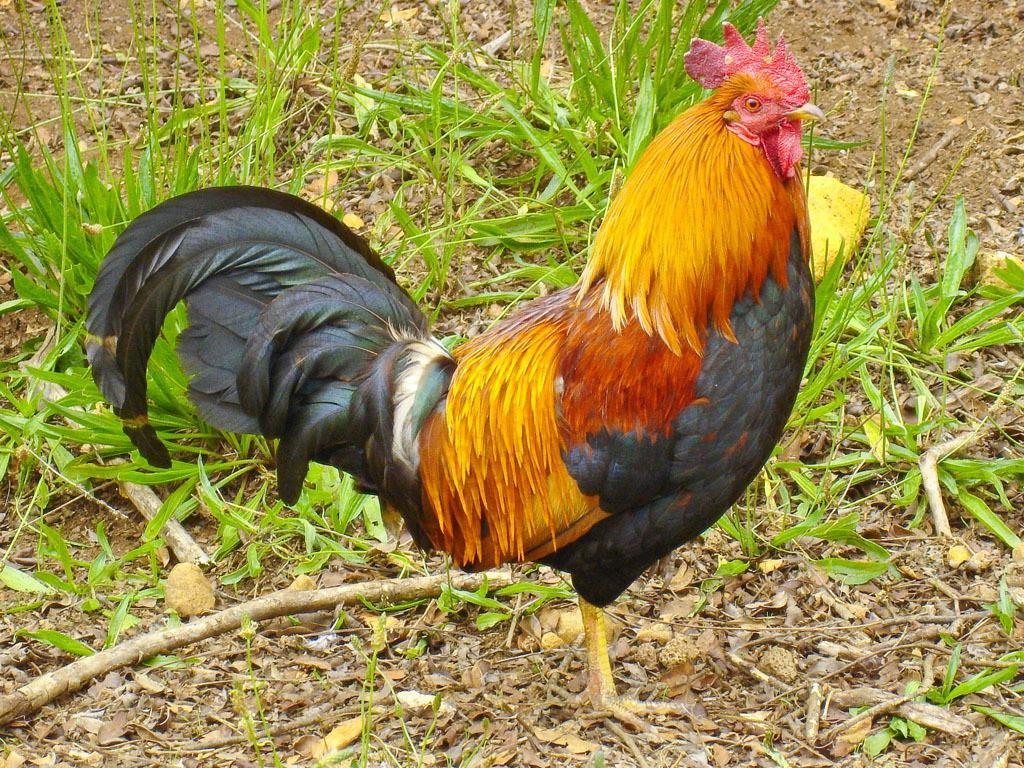Could you give a brief overview of what you see in this image? In this picture we can see a cock standing on the ground beside the grass. 